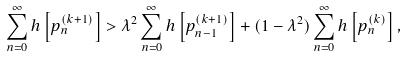<formula> <loc_0><loc_0><loc_500><loc_500>\sum _ { n = 0 } ^ { \infty } h \left [ p _ { n } ^ { ( k + 1 ) } \right ] > \lambda ^ { 2 } \sum _ { n = 0 } ^ { \infty } h \left [ p _ { n - 1 } ^ { ( k + 1 ) } \right ] + ( 1 - \lambda ^ { 2 } ) \sum _ { n = 0 } ^ { \infty } h \left [ p _ { n } ^ { ( k ) } \right ] ,</formula> 